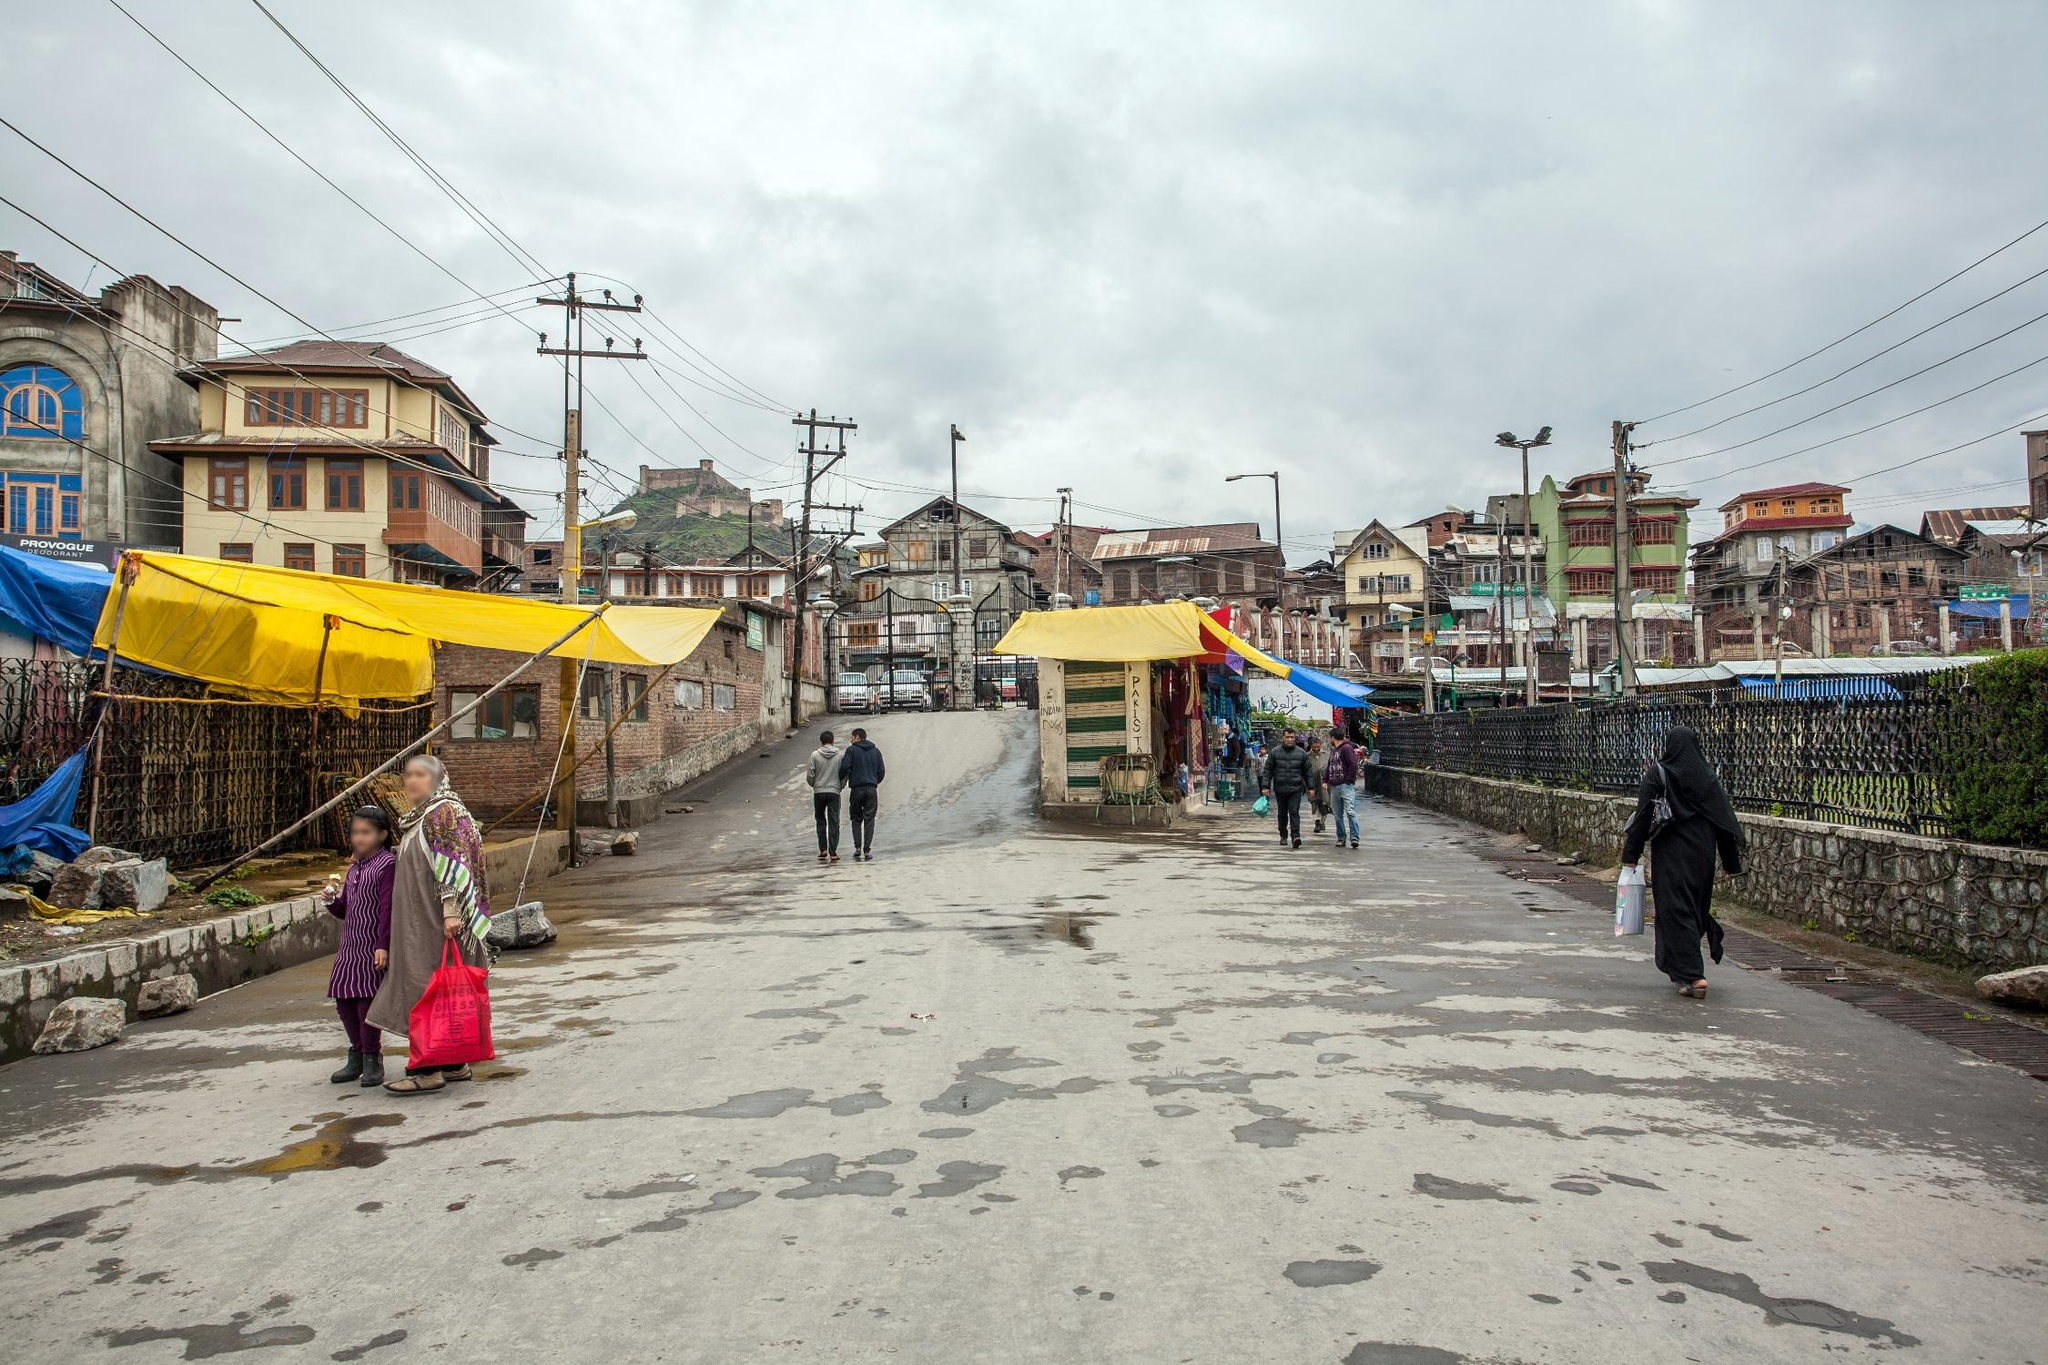How do people in the image seem to be reacting to the weather? Despite the overcast sky and presence of puddles, the people in the image continue with their daily routines, with some carrying umbrellas and others dressed in weather-appropriate clothing. This indicates a level of adaptability and resilience to the frequent dreary weather conditions in Srinagar. 